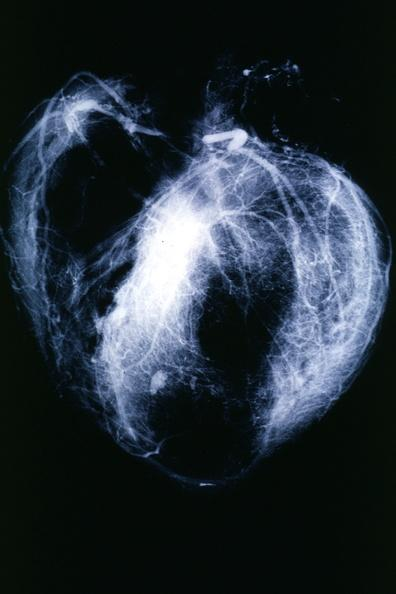what is present?
Answer the question using a single word or phrase. Angiogram 